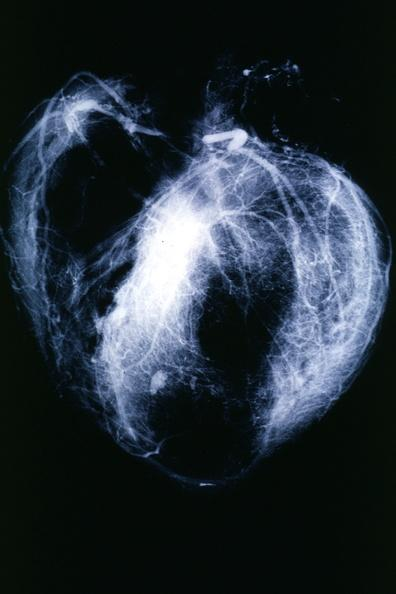what is present?
Answer the question using a single word or phrase. Angiogram 